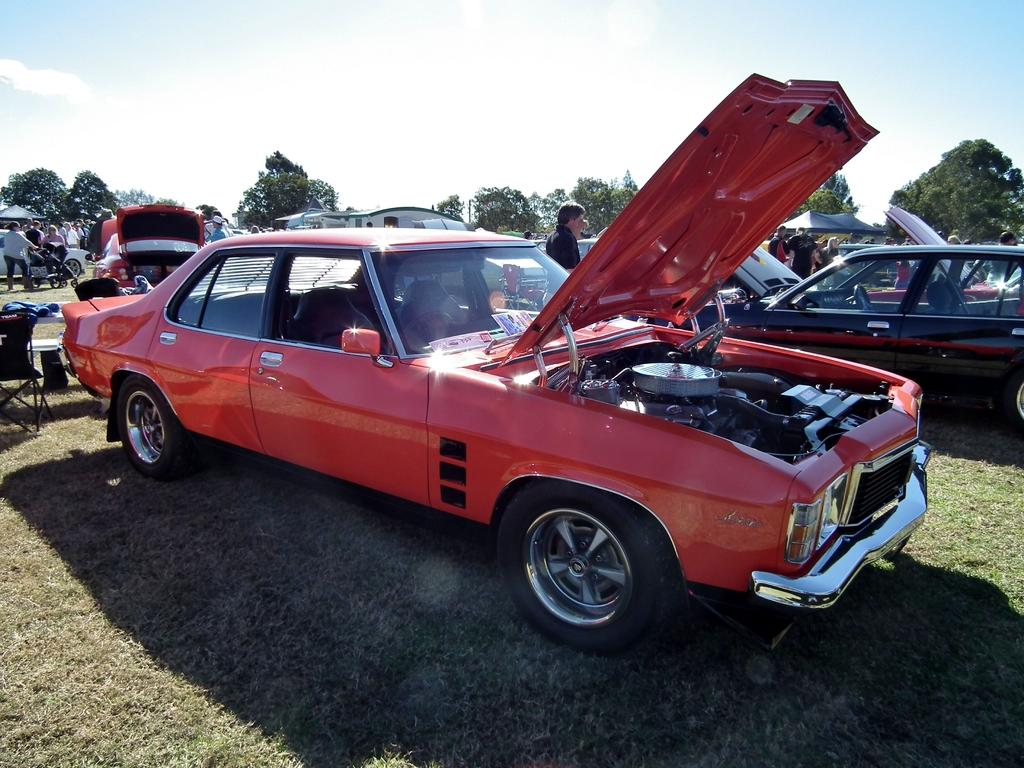What is located in the center of the image? There are cars in the center of the image. Can you describe the people visible in the image? There are people visible in the image. What can be seen in the background of the image? There are trees and the sky visible in the background of the image. What type of ground surface is at the bottom of the image? There is grass at the bottom of the image. How many friends can be seen with the spiders in the image? There are no spiders or friends present in the image. 